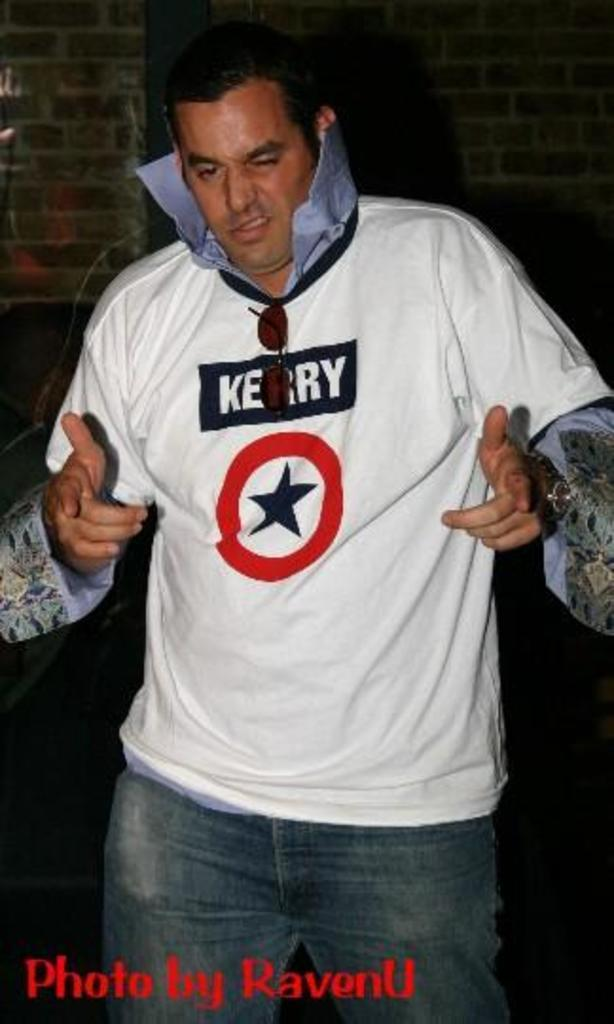Provide a one-sentence caption for the provided image. A man with a popped collar and a shirt with "Kerry" on it. 